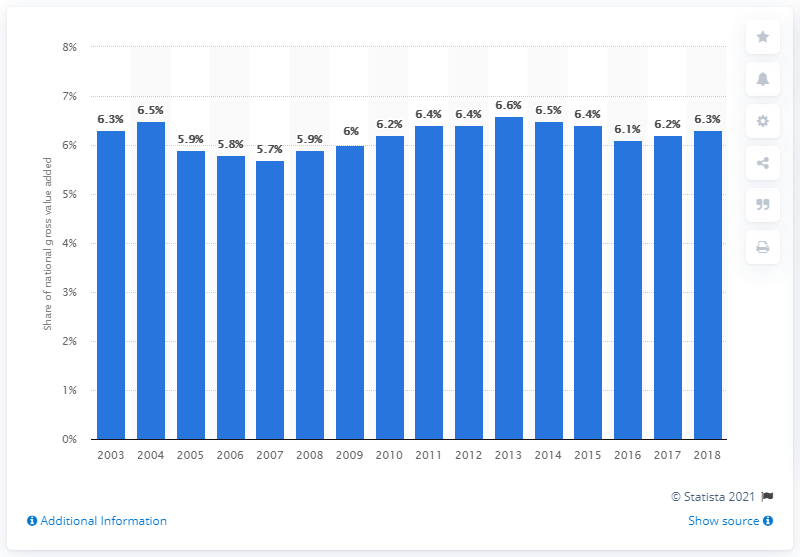Outline some significant characteristics in this image. In 2018, the agri-food sector accounted for 6.3% of the total economy's gross value added. 